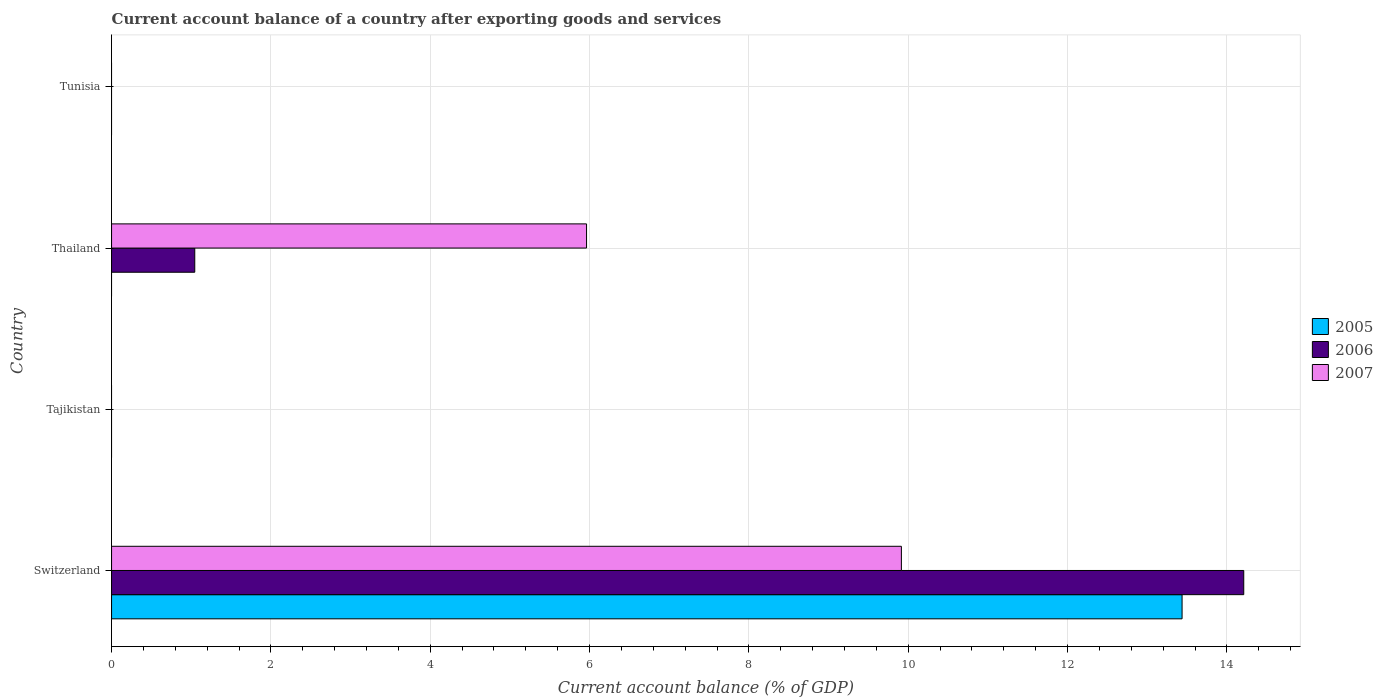How many bars are there on the 1st tick from the bottom?
Your answer should be very brief. 3. What is the label of the 3rd group of bars from the top?
Your response must be concise. Tajikistan. In how many cases, is the number of bars for a given country not equal to the number of legend labels?
Offer a terse response. 3. Across all countries, what is the maximum account balance in 2006?
Your response must be concise. 14.21. Across all countries, what is the minimum account balance in 2005?
Make the answer very short. 0. In which country was the account balance in 2007 maximum?
Ensure brevity in your answer.  Switzerland. What is the total account balance in 2005 in the graph?
Offer a terse response. 13.44. What is the difference between the account balance in 2006 in Switzerland and that in Thailand?
Offer a terse response. 13.17. What is the difference between the account balance in 2006 in Tunisia and the account balance in 2005 in Switzerland?
Your answer should be very brief. -13.44. What is the average account balance in 2007 per country?
Offer a very short reply. 3.97. What is the difference between the account balance in 2007 and account balance in 2006 in Thailand?
Make the answer very short. 4.92. What is the ratio of the account balance in 2007 in Switzerland to that in Thailand?
Your answer should be compact. 1.66. Is the difference between the account balance in 2007 in Switzerland and Thailand greater than the difference between the account balance in 2006 in Switzerland and Thailand?
Provide a succinct answer. No. What is the difference between the highest and the lowest account balance in 2005?
Provide a short and direct response. 13.44. Is it the case that in every country, the sum of the account balance in 2006 and account balance in 2005 is greater than the account balance in 2007?
Provide a short and direct response. No. How many bars are there?
Ensure brevity in your answer.  5. Are all the bars in the graph horizontal?
Give a very brief answer. Yes. How are the legend labels stacked?
Your answer should be very brief. Vertical. What is the title of the graph?
Your answer should be very brief. Current account balance of a country after exporting goods and services. Does "2009" appear as one of the legend labels in the graph?
Offer a terse response. No. What is the label or title of the X-axis?
Your answer should be very brief. Current account balance (% of GDP). What is the Current account balance (% of GDP) of 2005 in Switzerland?
Your answer should be compact. 13.44. What is the Current account balance (% of GDP) of 2006 in Switzerland?
Ensure brevity in your answer.  14.21. What is the Current account balance (% of GDP) of 2007 in Switzerland?
Keep it short and to the point. 9.91. What is the Current account balance (% of GDP) in 2005 in Thailand?
Offer a very short reply. 0. What is the Current account balance (% of GDP) in 2006 in Thailand?
Your answer should be compact. 1.04. What is the Current account balance (% of GDP) in 2007 in Thailand?
Your answer should be compact. 5.96. What is the Current account balance (% of GDP) of 2005 in Tunisia?
Ensure brevity in your answer.  0. What is the Current account balance (% of GDP) of 2007 in Tunisia?
Provide a short and direct response. 0. Across all countries, what is the maximum Current account balance (% of GDP) of 2005?
Offer a terse response. 13.44. Across all countries, what is the maximum Current account balance (% of GDP) of 2006?
Your response must be concise. 14.21. Across all countries, what is the maximum Current account balance (% of GDP) in 2007?
Offer a terse response. 9.91. Across all countries, what is the minimum Current account balance (% of GDP) in 2006?
Your answer should be very brief. 0. What is the total Current account balance (% of GDP) in 2005 in the graph?
Ensure brevity in your answer.  13.44. What is the total Current account balance (% of GDP) in 2006 in the graph?
Provide a succinct answer. 15.26. What is the total Current account balance (% of GDP) of 2007 in the graph?
Your answer should be very brief. 15.88. What is the difference between the Current account balance (% of GDP) of 2006 in Switzerland and that in Thailand?
Give a very brief answer. 13.17. What is the difference between the Current account balance (% of GDP) of 2007 in Switzerland and that in Thailand?
Ensure brevity in your answer.  3.95. What is the difference between the Current account balance (% of GDP) of 2005 in Switzerland and the Current account balance (% of GDP) of 2006 in Thailand?
Your answer should be compact. 12.39. What is the difference between the Current account balance (% of GDP) of 2005 in Switzerland and the Current account balance (% of GDP) of 2007 in Thailand?
Provide a short and direct response. 7.48. What is the difference between the Current account balance (% of GDP) in 2006 in Switzerland and the Current account balance (% of GDP) in 2007 in Thailand?
Provide a short and direct response. 8.25. What is the average Current account balance (% of GDP) of 2005 per country?
Ensure brevity in your answer.  3.36. What is the average Current account balance (% of GDP) in 2006 per country?
Provide a short and direct response. 3.81. What is the average Current account balance (% of GDP) of 2007 per country?
Your answer should be compact. 3.97. What is the difference between the Current account balance (% of GDP) in 2005 and Current account balance (% of GDP) in 2006 in Switzerland?
Your response must be concise. -0.77. What is the difference between the Current account balance (% of GDP) of 2005 and Current account balance (% of GDP) of 2007 in Switzerland?
Your answer should be compact. 3.52. What is the difference between the Current account balance (% of GDP) in 2006 and Current account balance (% of GDP) in 2007 in Switzerland?
Offer a terse response. 4.3. What is the difference between the Current account balance (% of GDP) in 2006 and Current account balance (% of GDP) in 2007 in Thailand?
Offer a very short reply. -4.92. What is the ratio of the Current account balance (% of GDP) of 2006 in Switzerland to that in Thailand?
Ensure brevity in your answer.  13.61. What is the ratio of the Current account balance (% of GDP) of 2007 in Switzerland to that in Thailand?
Offer a very short reply. 1.66. What is the difference between the highest and the lowest Current account balance (% of GDP) in 2005?
Offer a terse response. 13.44. What is the difference between the highest and the lowest Current account balance (% of GDP) in 2006?
Ensure brevity in your answer.  14.21. What is the difference between the highest and the lowest Current account balance (% of GDP) in 2007?
Offer a very short reply. 9.91. 